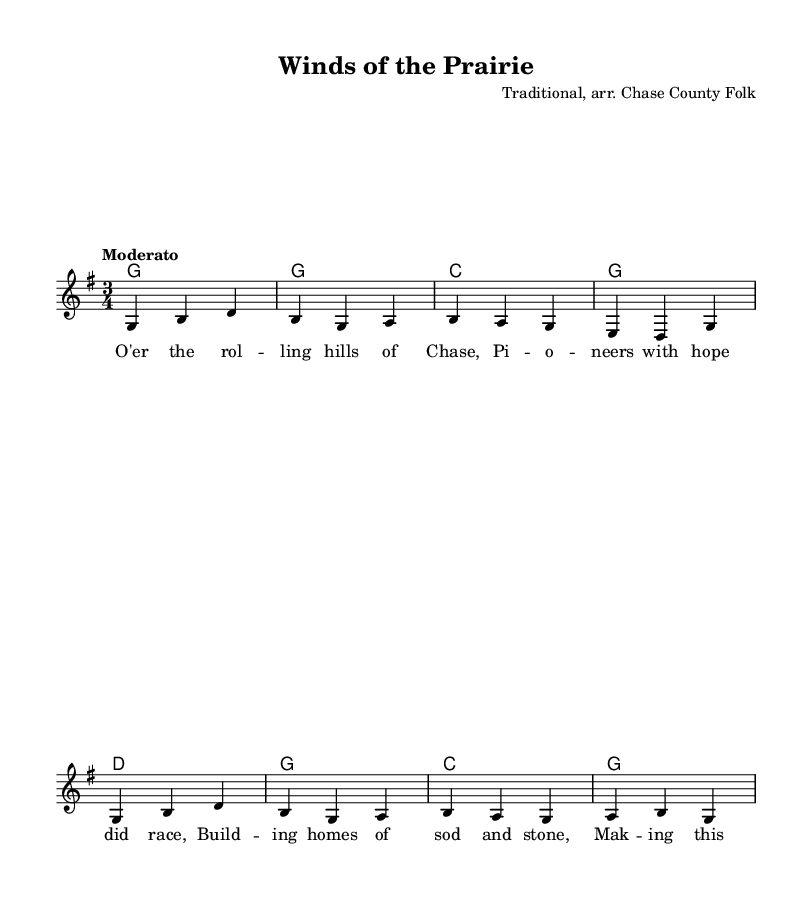What is the key signature of this music? The key signature is G major, indicated by one sharp (F#) at the beginning of the staff.
Answer: G major What is the time signature of this piece? The time signature is 3/4, indicated by the numbers at the beginning of the staff that shows there are three beats in each measure and the quarter note gets one beat.
Answer: 3/4 What is the tempo marking for this composition? The tempo marking is "Moderato," which suggests a moderate pace for the piece, as indicated in the tempo section.
Answer: Moderato What is the name of the piece? The title of the piece, as noted at the top of the sheet music, is "Winds of the Prairie."
Answer: Winds of the Prairie Identify a chord present in the harmony. The chord labeled in the harmony section includes a G chord, which is the first chord shown in the chord progression.
Answer: G How many measures are in the melody? The melody has eight measures, as counted by the number of vertical lines (bar lines) on the staff that separate the phrases.
Answer: Eight Which lyrical theme does this ballad address? The lyrics convey the theme of pioneer settlement, focusing on the struggles and hopes of pioneers who built homes in the Midwest.
Answer: Pioneer settlement 